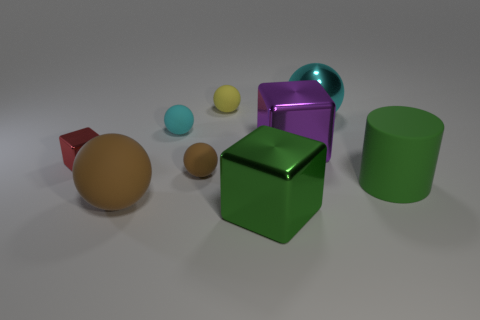What would you say is the primary light source in this scene? The primary light source in the image seems to be coming from the top left, based on the shadows cast by the objects and the highlights visible on their surfaces. 